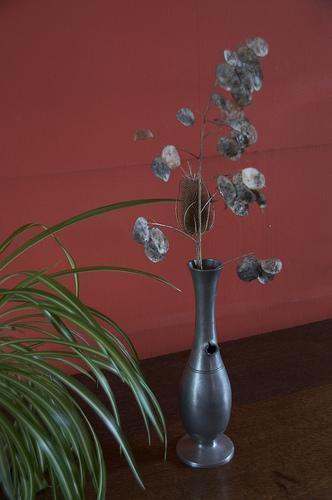How many vases on the table?
Give a very brief answer. 1. 